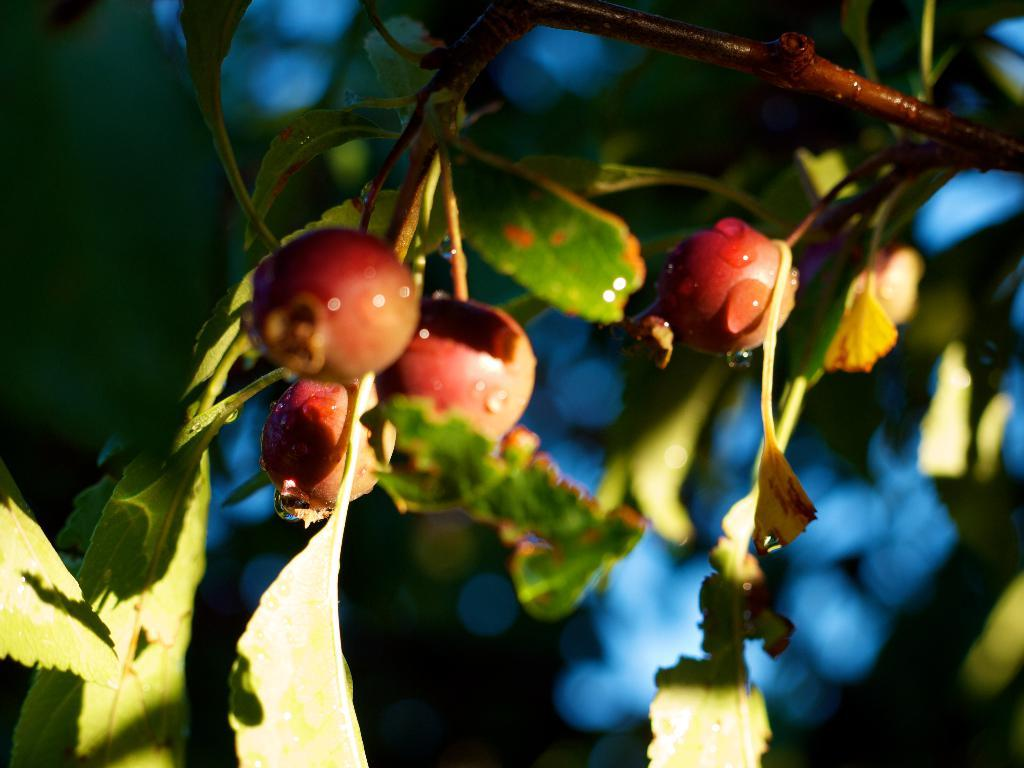What type of food items can be seen in the image? There are fruits in the image. What parts of the fruits are visible in the image? There are leaves and stems in the image. How would you describe the background of the image? The background of the image is blurred. What operation is being performed on the fruits in the image? There is no operation being performed on the fruits in the image; they are simply depicted as they are. 